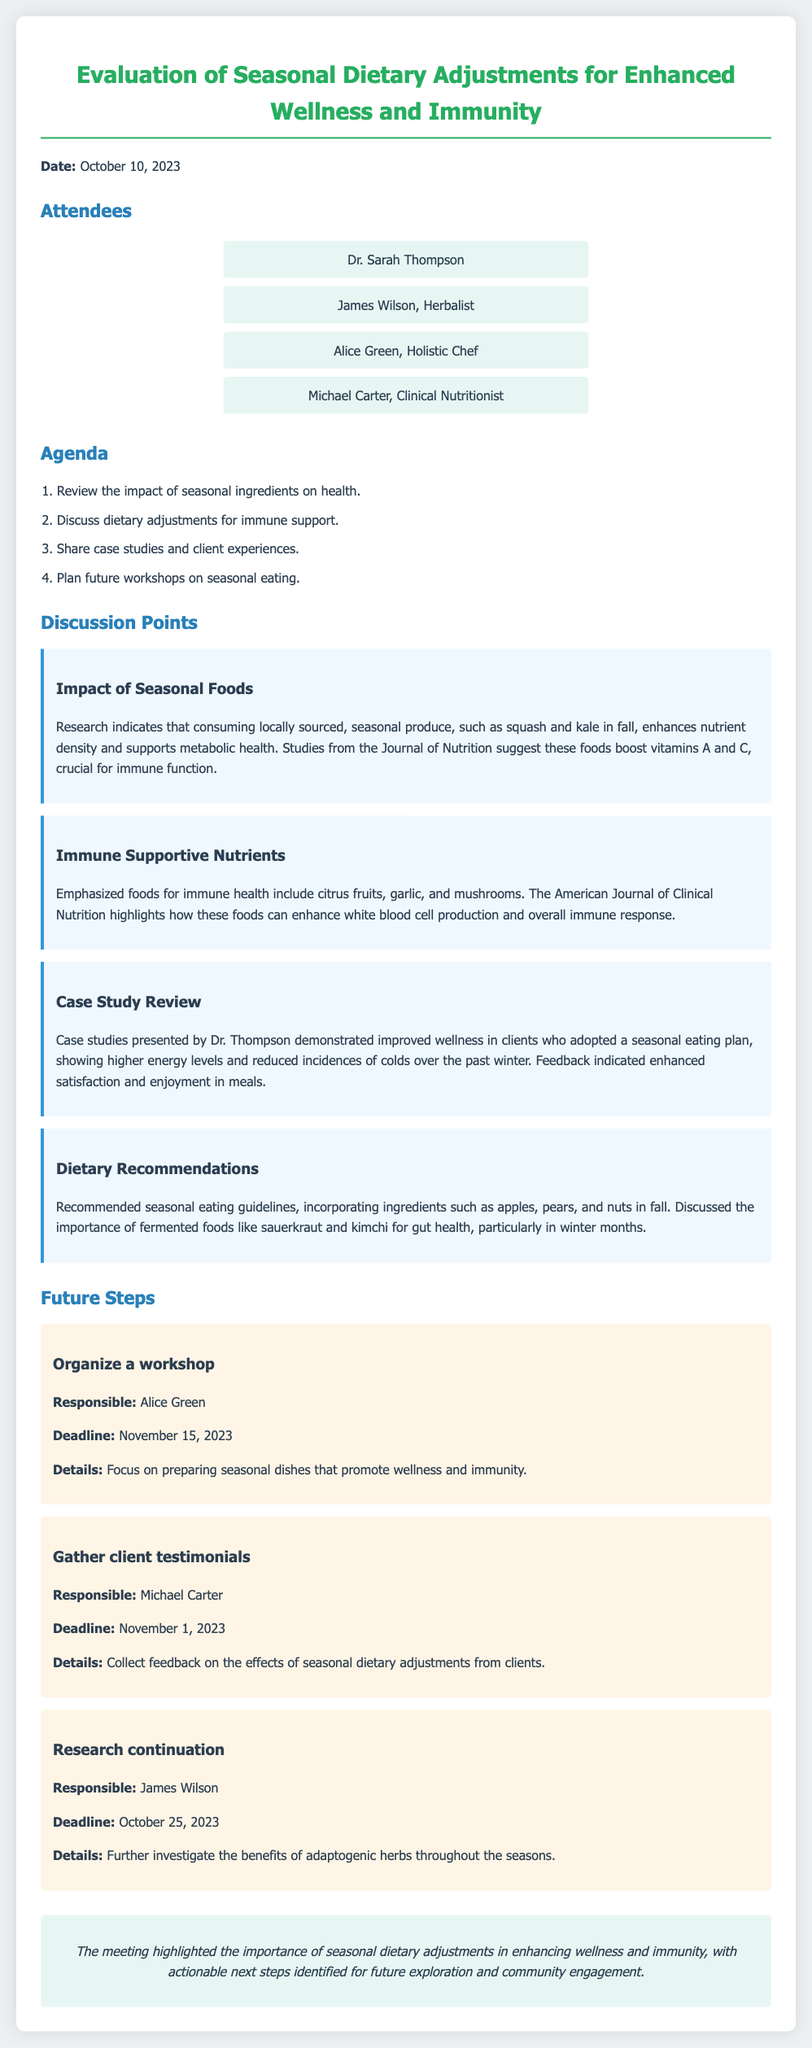What is the date of the meeting? The date of the meeting is stated at the beginning of the document.
Answer: October 10, 2023 Who is responsible for organizing the workshop? The document mentions the responsibility for organizing the workshop under future steps.
Answer: Alice Green What is one of the emphasized foods for immune health? The document lists foods that support immune health in the discussion points section.
Answer: Garlic What was the significant finding from Dr. Thompson's case studies? The case studies presented in the document highlight specific outcomes related to seasonal eating.
Answer: Improved wellness What is the deadline for gathering client testimonials? The document lists specific deadlines in the future steps section.
Answer: November 1, 2023 What are the recommended seasonal foods mentioned for fall? The discussion points outline specific dietary recommendations for the fall season.
Answer: Apples, pears, and nuts What benefit do seasonal foods provide according to the document? The impact of seasonal foods is discussed in relation to health benefits in the discussion points.
Answer: Enhances nutrient density Which journal is cited regarding the impact of seasonal ingredients? The document references specific journals that support statements made during the meeting.
Answer: Journal of Nutrition What type of foods does the document recommend focusing on for winter gut health? The dietary recommendations include certain foods that support gut health during winter.
Answer: Fermented foods 